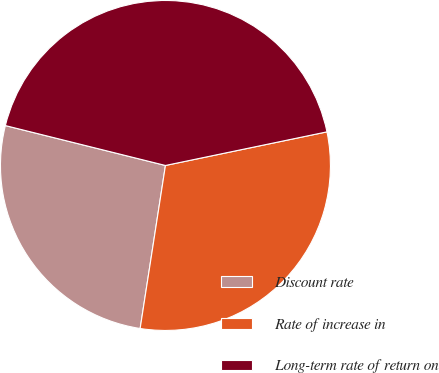Convert chart to OTSL. <chart><loc_0><loc_0><loc_500><loc_500><pie_chart><fcel>Discount rate<fcel>Rate of increase in<fcel>Long-term rate of return on<nl><fcel>26.44%<fcel>30.72%<fcel>42.85%<nl></chart> 